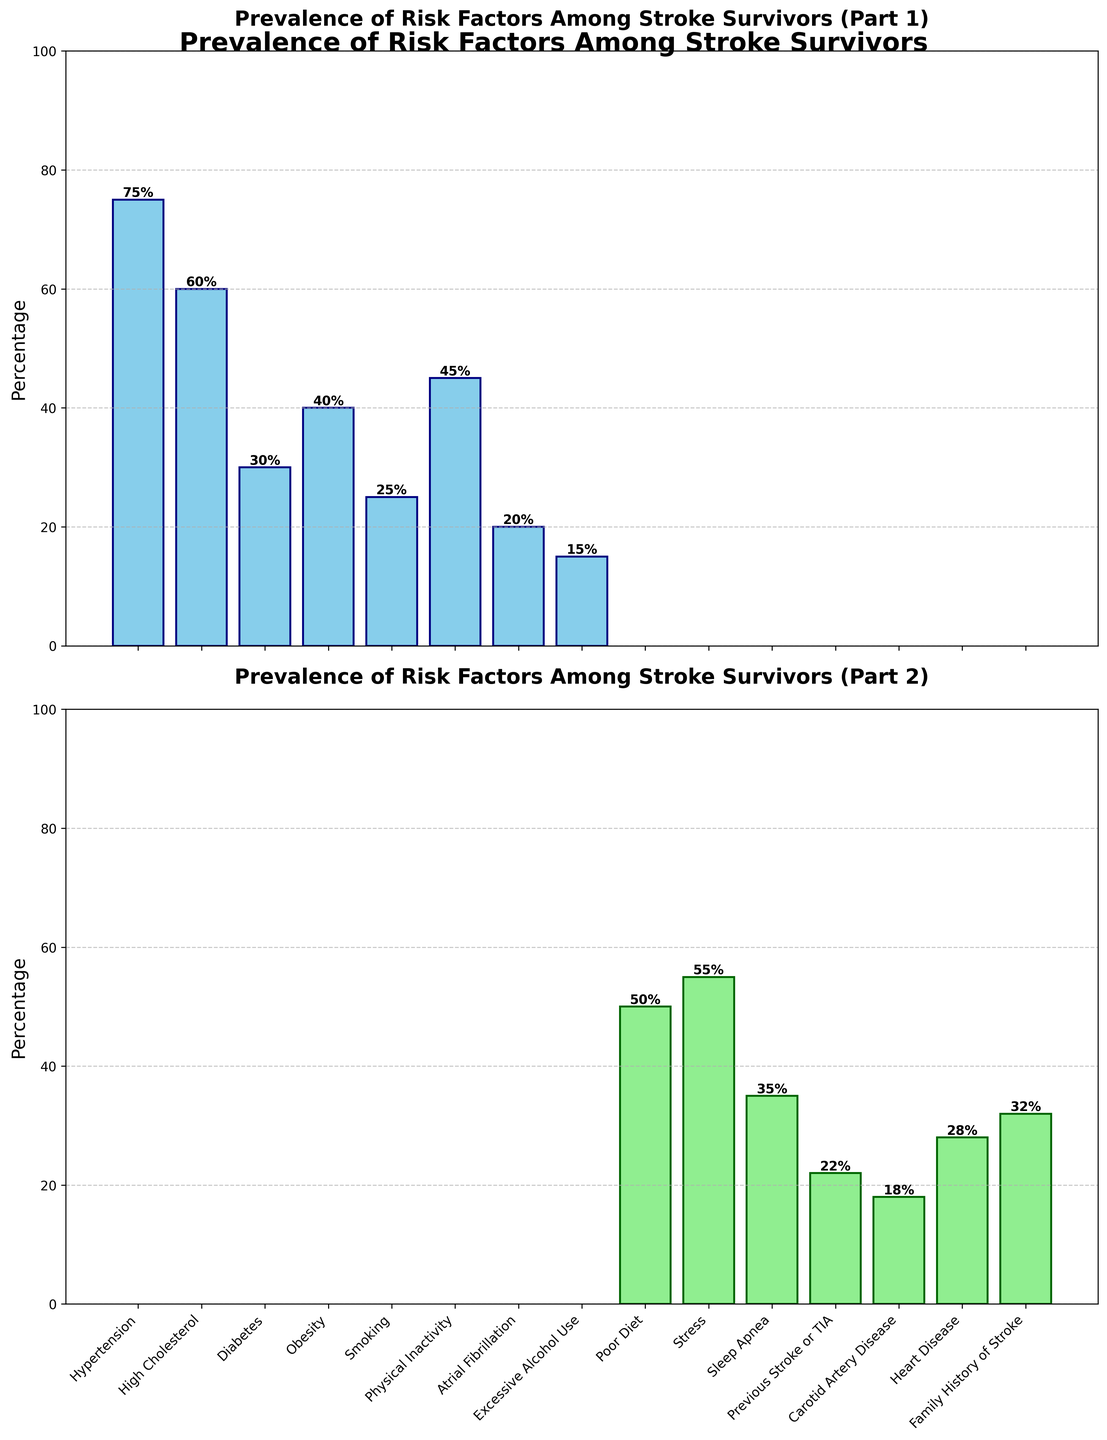Which risk factor has the highest prevalence in the figure? The first subplot shows Hypertension with a bar reaching 75%, which is the tallest bar among all the listed risk factors.
Answer: Hypertension How much more prevalent is Hypertension compared to Atrial Fibrillation? Hypertension is at 75% and Atrial Fibrillation is at 20%. The difference between them is 75% - 20% = 55%.
Answer: 55% Which risk factor has a prevalence of 35% and what is its position in the plot? In the second subplot, Sleep Apnea has a prevalence bar reaching 35%, which is the middle bar among the second group of risk factors.
Answer: Sleep Apnea, middle bar in second subplot What is the average prevalence of High Cholesterol, Diabetes, and Obesity? High Cholesterol is 60%, Diabetes is 30%, and Obesity is 40%. The average is calculated as (60% + 30% + 40%) / 3 = 43.33%.
Answer: 43.33% Which two risk factors are less prevalent than Smoking? In the first subplot, Smoking has a prevalence of 25%. In the subsequent subplot, Atrial Fibrillation (20%) and Excessive Alcohol Use (15%) are both less prevalent.
Answer: Atrial Fibrillation, Excessive Alcohol Use Among Hypertension, Physical Inactivity, and Poor Diet, which two are closest in prevalence? Hypertension is 75%, Physical Inactivity is 45%, and Poor Diet is 50%. Physical Inactivity and Poor Diet, with only a 5% difference, are closest.
Answer: Physical Inactivity, Poor Diet What is the total prevalence of risk factors starting with 'P' (Physical Inactivity, Poor Diet, Previous Stroke or TIA)? Summing up the percentages: Physical Inactivity (45%) + Poor Diet (50%) + Previous Stroke or TIA (22%) = 117%.
Answer: 117% Is Stress more prevalent than Heart Disease? By how much? Stress has a prevalence of 55%, and Heart Disease has a prevalence of 28%. Stress is more prevalent by 55% - 28% = 27%.
Answer: 27% Which risk factor is immediately to the right of Obesity in the first subplot, and what is its prevalence? The risk factor positioned right next to Obesity is Smoking, with a prevalence of 25%.
Answer: Smoking, 25% Which visual attribute differentiates the two subplots, and what might be the reason for this distinction? The first subplot uses sky blue bars, while the second uses light green bars. The differentiation helps in visually separating the two groups of risk factors for better clarity.
Answer: Color, to distinguish groups 